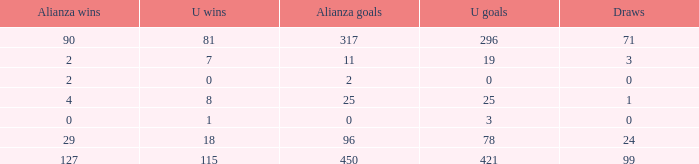What is the total number of U Wins, when Alianza Goals is "0", and when U Goals is greater than 3? 0.0. 